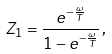Convert formula to latex. <formula><loc_0><loc_0><loc_500><loc_500>Z _ { 1 } = \frac { e ^ { - \frac { \omega } { T } } } { 1 - e ^ { - \frac { \omega } { T } } } \, ,</formula> 